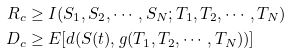Convert formula to latex. <formula><loc_0><loc_0><loc_500><loc_500>R _ { c } & \geq I ( S _ { 1 } , S _ { 2 } , \cdots , S _ { N } ; T _ { 1 } , T _ { 2 } , \cdots , T _ { N } ) \\ D _ { c } & \geq E [ d ( S ( t ) , g ( T _ { 1 } , T _ { 2 } , \cdots , T _ { N } ) ) ]</formula> 